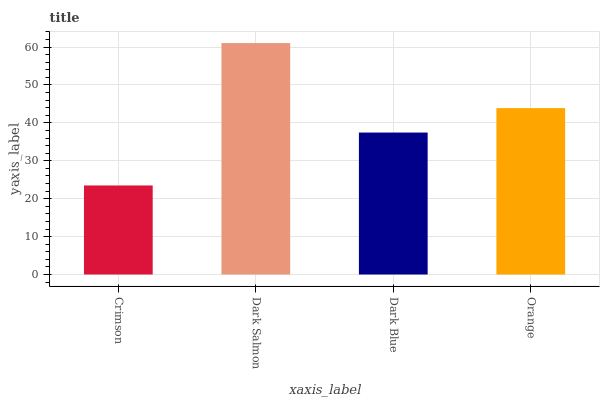Is Crimson the minimum?
Answer yes or no. Yes. Is Dark Salmon the maximum?
Answer yes or no. Yes. Is Dark Blue the minimum?
Answer yes or no. No. Is Dark Blue the maximum?
Answer yes or no. No. Is Dark Salmon greater than Dark Blue?
Answer yes or no. Yes. Is Dark Blue less than Dark Salmon?
Answer yes or no. Yes. Is Dark Blue greater than Dark Salmon?
Answer yes or no. No. Is Dark Salmon less than Dark Blue?
Answer yes or no. No. Is Orange the high median?
Answer yes or no. Yes. Is Dark Blue the low median?
Answer yes or no. Yes. Is Dark Salmon the high median?
Answer yes or no. No. Is Dark Salmon the low median?
Answer yes or no. No. 